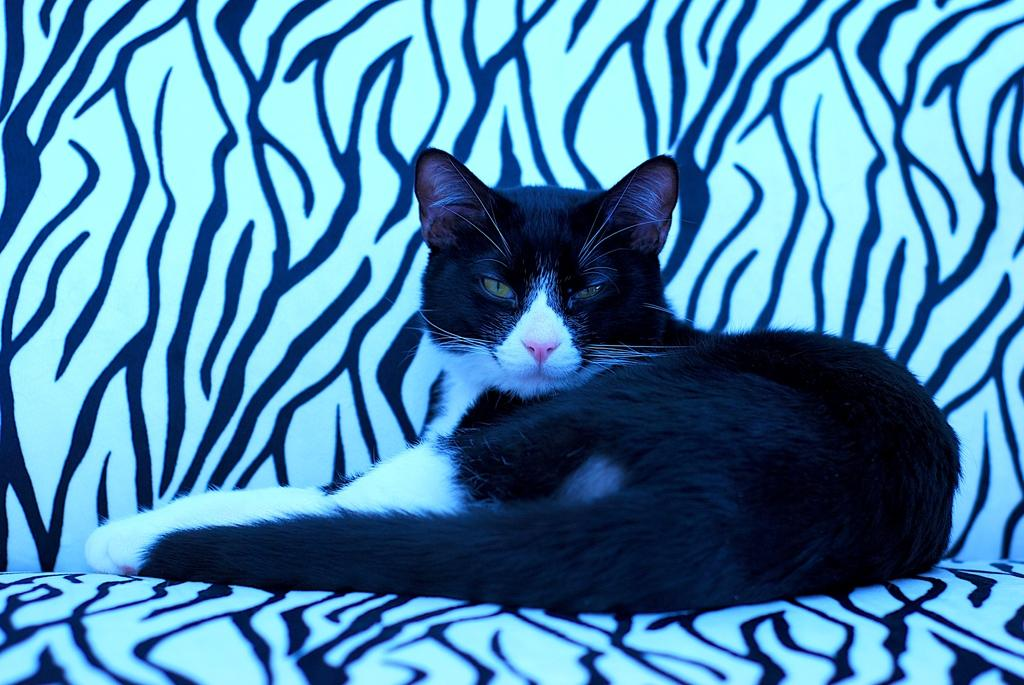What type of animal is in the picture? There is a cat in the picture. What is the cat doing in the picture? The cat is sitting on an object. What colors can be seen on the cat? The cat is black and white in color. What type of umbrella is the cat holding in the picture? There is no umbrella present in the image, and the cat is not holding anything. 